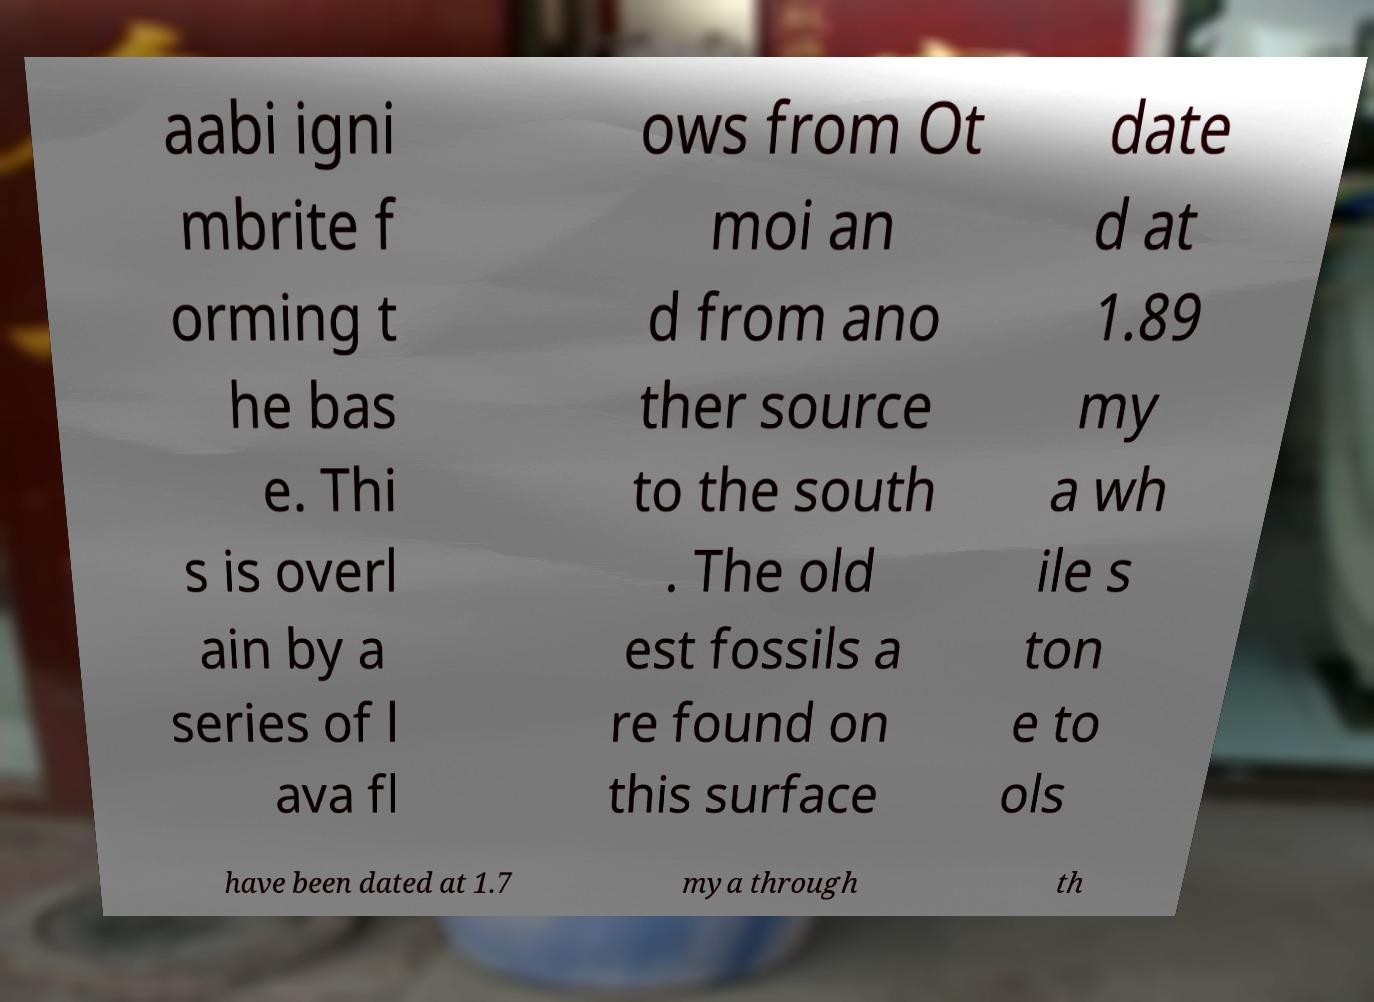What messages or text are displayed in this image? I need them in a readable, typed format. aabi igni mbrite f orming t he bas e. Thi s is overl ain by a series of l ava fl ows from Ot moi an d from ano ther source to the south . The old est fossils a re found on this surface date d at 1.89 my a wh ile s ton e to ols have been dated at 1.7 mya through th 